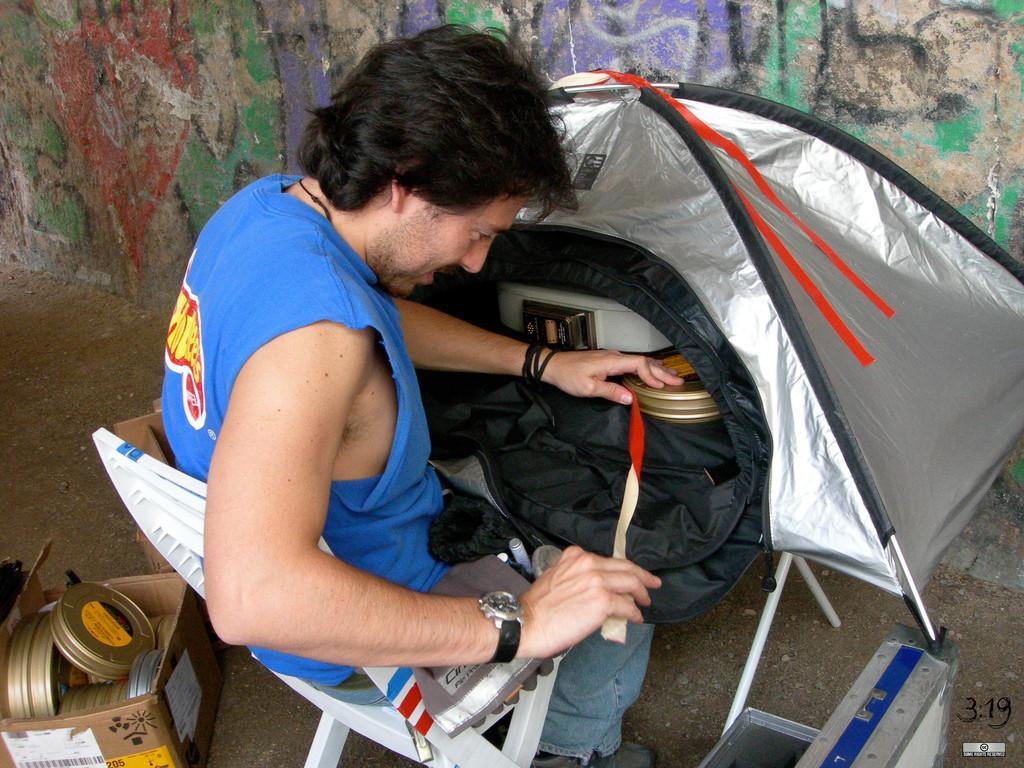Describe this image in one or two sentences. In this image I can see a person sitting on the chair. The person is wearing blue shirt, blue pant and holding some object. Background I can see a wall in multi color. 